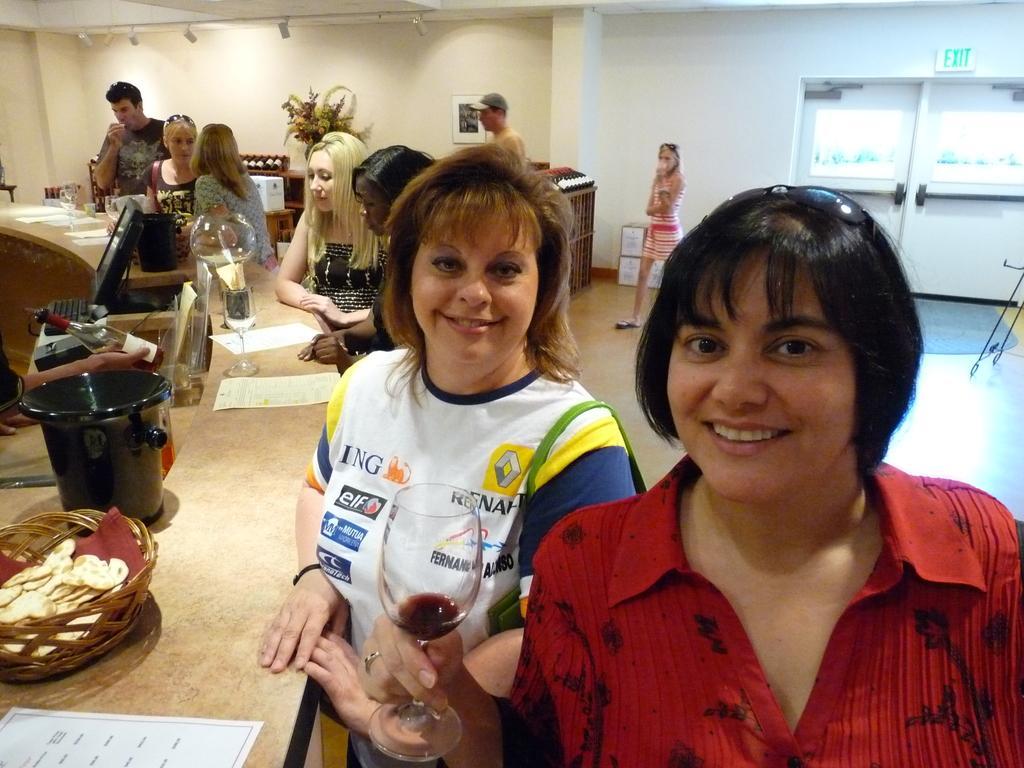Please provide a concise description of this image. In this picture there is a desk on the left side of the image and there are people those who are standing around the desk and desk contains papers, glasses, and a basket on it, there is a computer on the left side of the image and there are other people and a desk in the background area of the image. 